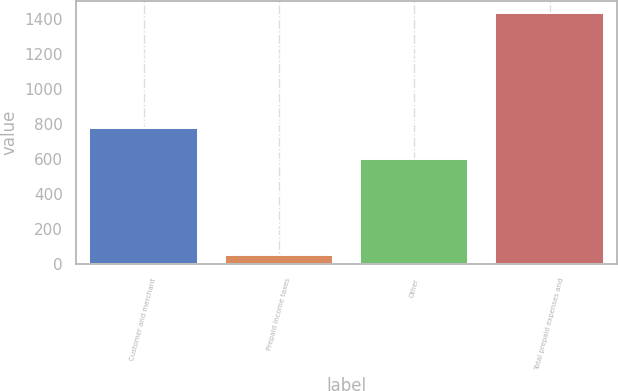Convert chart to OTSL. <chart><loc_0><loc_0><loc_500><loc_500><bar_chart><fcel>Customer and merchant<fcel>Prepaid income taxes<fcel>Other<fcel>Total prepaid expenses and<nl><fcel>778<fcel>51<fcel>603<fcel>1432<nl></chart> 